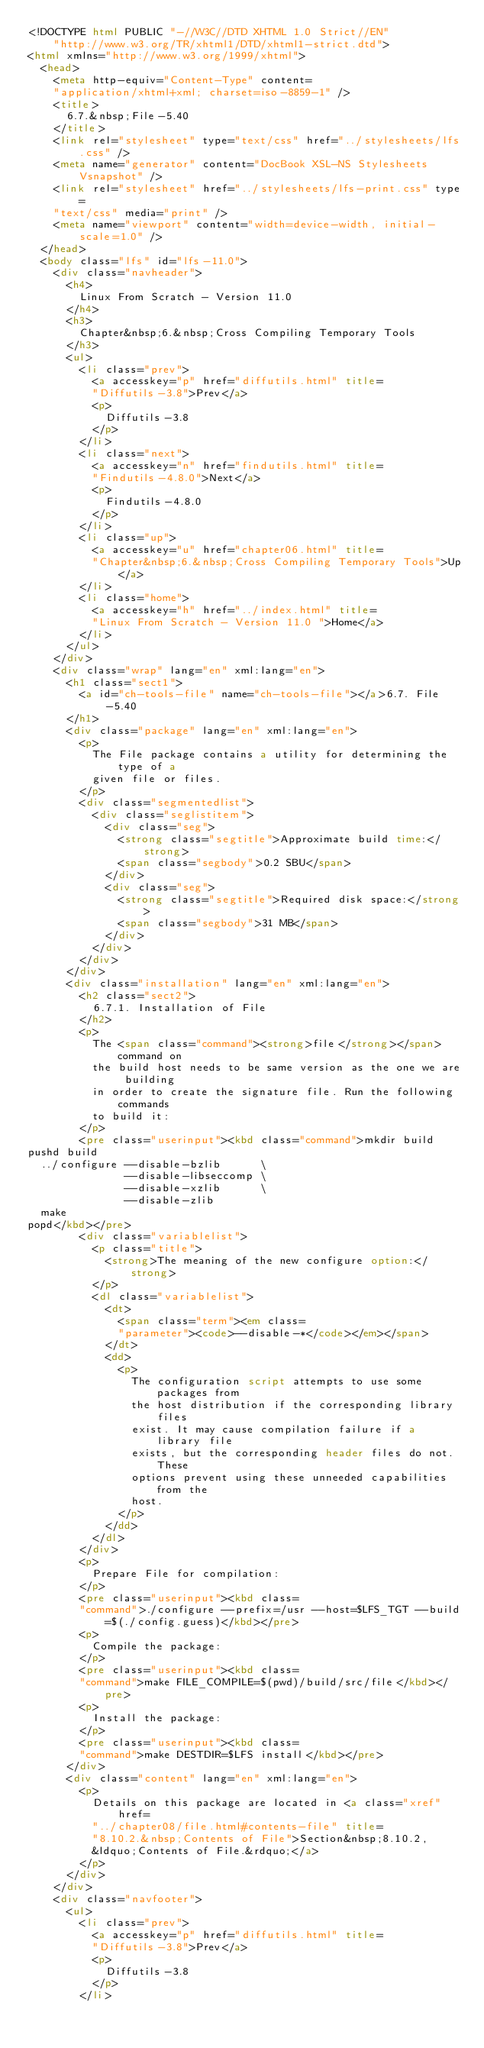<code> <loc_0><loc_0><loc_500><loc_500><_HTML_><!DOCTYPE html PUBLIC "-//W3C//DTD XHTML 1.0 Strict//EN"
    "http://www.w3.org/TR/xhtml1/DTD/xhtml1-strict.dtd">
<html xmlns="http://www.w3.org/1999/xhtml">
  <head>
    <meta http-equiv="Content-Type" content=
    "application/xhtml+xml; charset=iso-8859-1" />
    <title>
      6.7.&nbsp;File-5.40
    </title>
    <link rel="stylesheet" type="text/css" href="../stylesheets/lfs.css" />
    <meta name="generator" content="DocBook XSL-NS Stylesheets Vsnapshot" />
    <link rel="stylesheet" href="../stylesheets/lfs-print.css" type=
    "text/css" media="print" />
    <meta name="viewport" content="width=device-width, initial-scale=1.0" />
  </head>
  <body class="lfs" id="lfs-11.0">
    <div class="navheader">
      <h4>
        Linux From Scratch - Version 11.0
      </h4>
      <h3>
        Chapter&nbsp;6.&nbsp;Cross Compiling Temporary Tools
      </h3>
      <ul>
        <li class="prev">
          <a accesskey="p" href="diffutils.html" title=
          "Diffutils-3.8">Prev</a>
          <p>
            Diffutils-3.8
          </p>
        </li>
        <li class="next">
          <a accesskey="n" href="findutils.html" title=
          "Findutils-4.8.0">Next</a>
          <p>
            Findutils-4.8.0
          </p>
        </li>
        <li class="up">
          <a accesskey="u" href="chapter06.html" title=
          "Chapter&nbsp;6.&nbsp;Cross Compiling Temporary Tools">Up</a>
        </li>
        <li class="home">
          <a accesskey="h" href="../index.html" title=
          "Linux From Scratch - Version 11.0 ">Home</a>
        </li>
      </ul>
    </div>
    <div class="wrap" lang="en" xml:lang="en">
      <h1 class="sect1">
        <a id="ch-tools-file" name="ch-tools-file"></a>6.7. File-5.40
      </h1>
      <div class="package" lang="en" xml:lang="en">
        <p>
          The File package contains a utility for determining the type of a
          given file or files.
        </p>
        <div class="segmentedlist">
          <div class="seglistitem">
            <div class="seg">
              <strong class="segtitle">Approximate build time:</strong>
              <span class="segbody">0.2 SBU</span>
            </div>
            <div class="seg">
              <strong class="segtitle">Required disk space:</strong>
              <span class="segbody">31 MB</span>
            </div>
          </div>
        </div>
      </div>
      <div class="installation" lang="en" xml:lang="en">
        <h2 class="sect2">
          6.7.1. Installation of File
        </h2>
        <p>
          The <span class="command"><strong>file</strong></span> command on
          the build host needs to be same version as the one we are building
          in order to create the signature file. Run the following commands
          to build it:
        </p>
        <pre class="userinput"><kbd class="command">mkdir build
pushd build
  ../configure --disable-bzlib      \
               --disable-libseccomp \
               --disable-xzlib      \
               --disable-zlib
  make
popd</kbd></pre>
        <div class="variablelist">
          <p class="title">
            <strong>The meaning of the new configure option:</strong>
          </p>
          <dl class="variablelist">
            <dt>
              <span class="term"><em class=
              "parameter"><code>--disable-*</code></em></span>
            </dt>
            <dd>
              <p>
                The configuration script attempts to use some packages from
                the host distribution if the corresponding library files
                exist. It may cause compilation failure if a library file
                exists, but the corresponding header files do not. These
                options prevent using these unneeded capabilities from the
                host.
              </p>
            </dd>
          </dl>
        </div>
        <p>
          Prepare File for compilation:
        </p>
        <pre class="userinput"><kbd class=
        "command">./configure --prefix=/usr --host=$LFS_TGT --build=$(./config.guess)</kbd></pre>
        <p>
          Compile the package:
        </p>
        <pre class="userinput"><kbd class=
        "command">make FILE_COMPILE=$(pwd)/build/src/file</kbd></pre>
        <p>
          Install the package:
        </p>
        <pre class="userinput"><kbd class=
        "command">make DESTDIR=$LFS install</kbd></pre>
      </div>
      <div class="content" lang="en" xml:lang="en">
        <p>
          Details on this package are located in <a class="xref" href=
          "../chapter08/file.html#contents-file" title=
          "8.10.2.&nbsp;Contents of File">Section&nbsp;8.10.2,
          &ldquo;Contents of File.&rdquo;</a>
        </p>
      </div>
    </div>
    <div class="navfooter">
      <ul>
        <li class="prev">
          <a accesskey="p" href="diffutils.html" title=
          "Diffutils-3.8">Prev</a>
          <p>
            Diffutils-3.8
          </p>
        </li></code> 